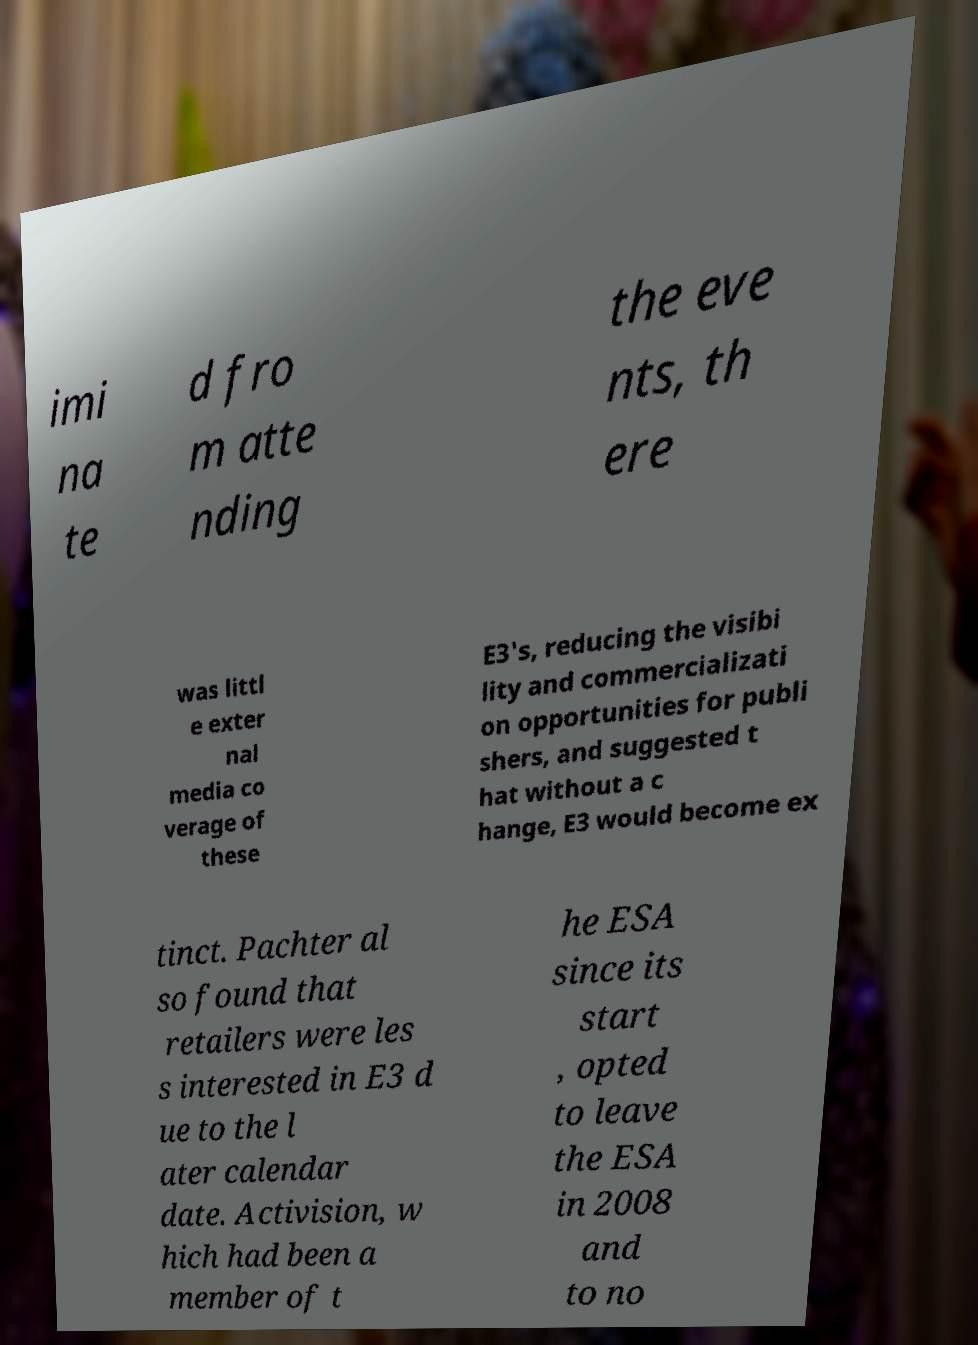Please identify and transcribe the text found in this image. imi na te d fro m atte nding the eve nts, th ere was littl e exter nal media co verage of these E3's, reducing the visibi lity and commercializati on opportunities for publi shers, and suggested t hat without a c hange, E3 would become ex tinct. Pachter al so found that retailers were les s interested in E3 d ue to the l ater calendar date. Activision, w hich had been a member of t he ESA since its start , opted to leave the ESA in 2008 and to no 